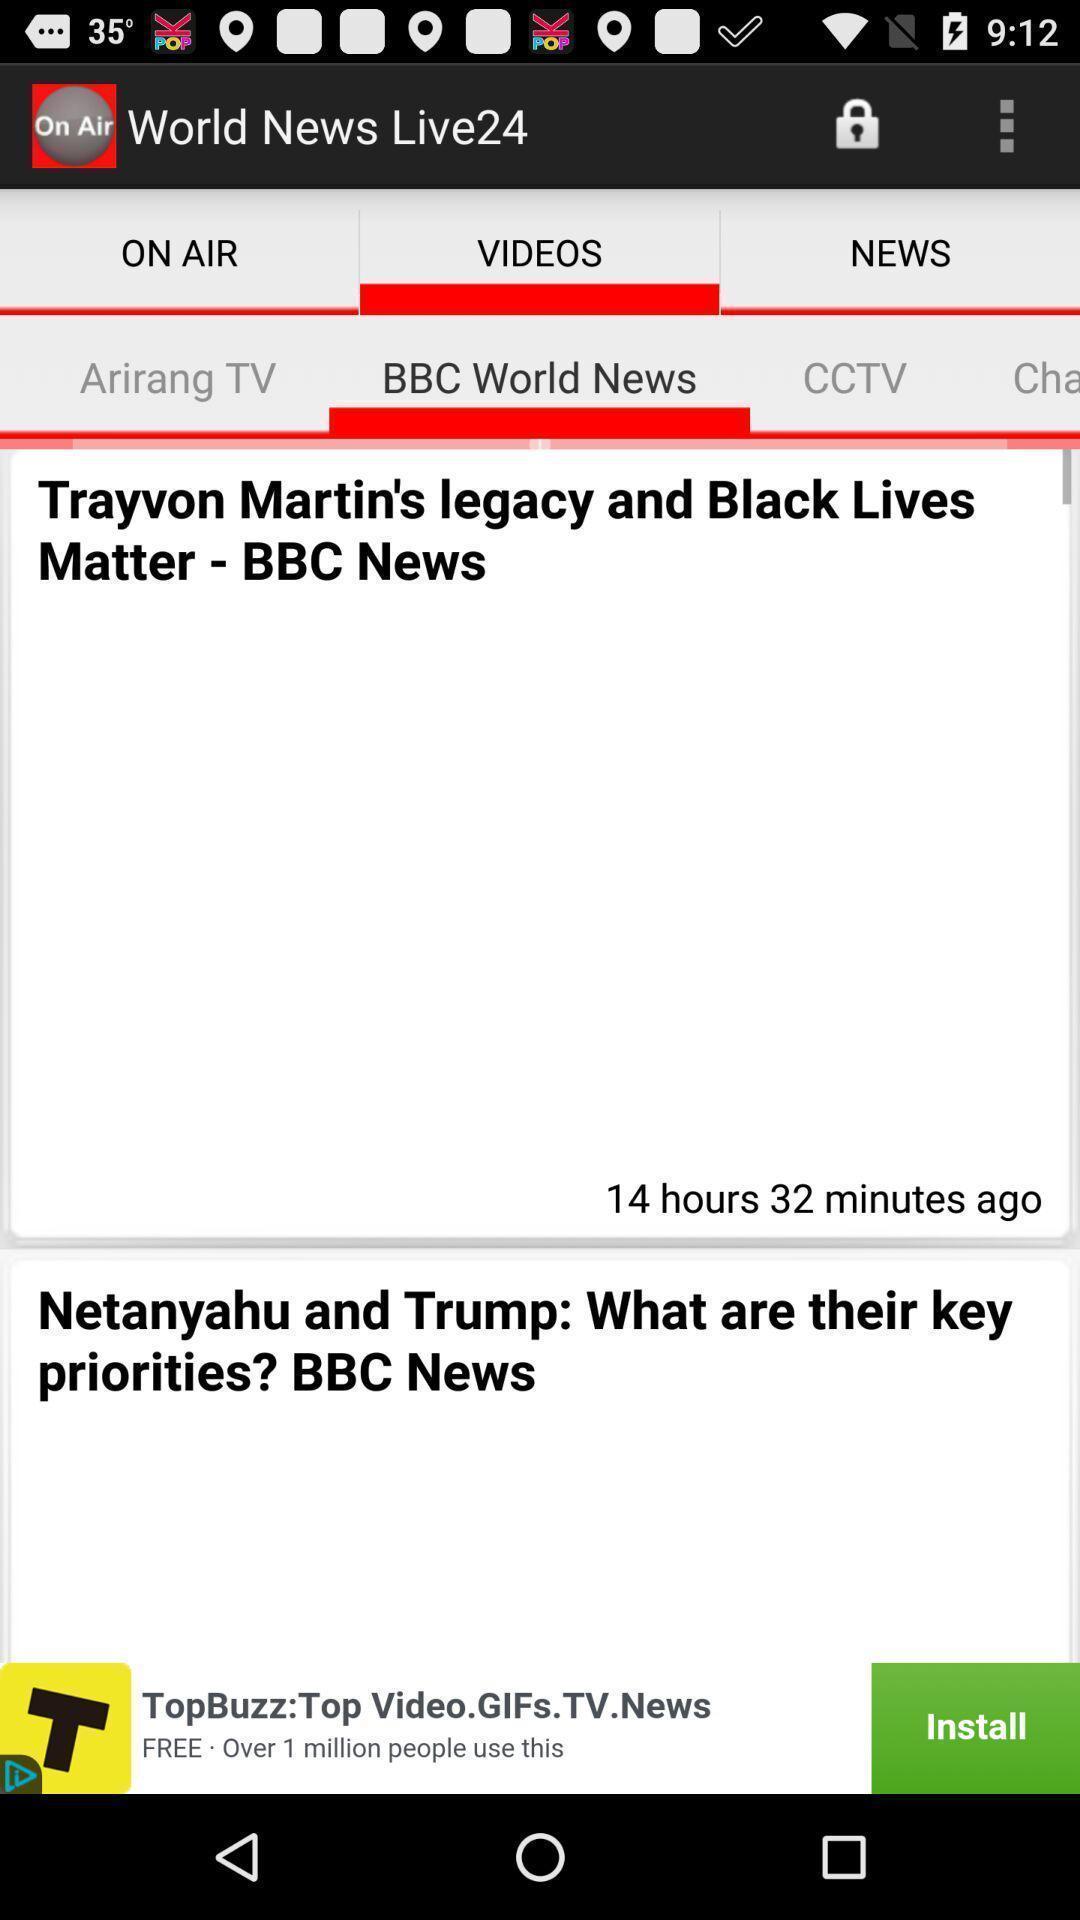Please provide a description for this image. Screen shows world news live. 